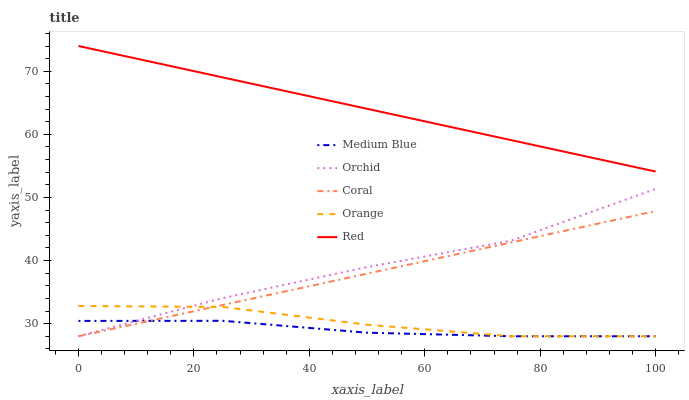Does Medium Blue have the minimum area under the curve?
Answer yes or no. Yes. Does Red have the maximum area under the curve?
Answer yes or no. Yes. Does Coral have the minimum area under the curve?
Answer yes or no. No. Does Coral have the maximum area under the curve?
Answer yes or no. No. Is Coral the smoothest?
Answer yes or no. Yes. Is Orchid the roughest?
Answer yes or no. Yes. Is Medium Blue the smoothest?
Answer yes or no. No. Is Medium Blue the roughest?
Answer yes or no. No. Does Orange have the lowest value?
Answer yes or no. Yes. Does Red have the lowest value?
Answer yes or no. No. Does Red have the highest value?
Answer yes or no. Yes. Does Coral have the highest value?
Answer yes or no. No. Is Coral less than Red?
Answer yes or no. Yes. Is Red greater than Orchid?
Answer yes or no. Yes. Does Medium Blue intersect Coral?
Answer yes or no. Yes. Is Medium Blue less than Coral?
Answer yes or no. No. Is Medium Blue greater than Coral?
Answer yes or no. No. Does Coral intersect Red?
Answer yes or no. No. 